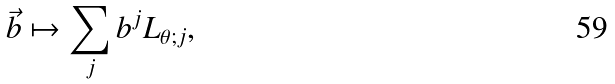<formula> <loc_0><loc_0><loc_500><loc_500>\vec { b } \mapsto \sum _ { j } b ^ { j } L _ { \theta ; j } ,</formula> 